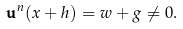Convert formula to latex. <formula><loc_0><loc_0><loc_500><loc_500>\mathbf u ^ { n } ( x + h ) = w + g \neq 0 .</formula> 